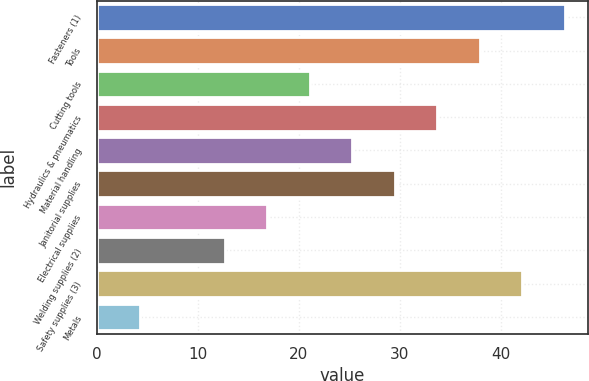<chart> <loc_0><loc_0><loc_500><loc_500><bar_chart><fcel>Fasteners (1)<fcel>Tools<fcel>Cutting tools<fcel>Hydraulics & pneumatics<fcel>Material handling<fcel>Janitorial supplies<fcel>Electrical supplies<fcel>Welding supplies (2)<fcel>Safety supplies (3)<fcel>Metals<nl><fcel>46.3<fcel>37.9<fcel>21.1<fcel>33.7<fcel>25.3<fcel>29.5<fcel>16.9<fcel>12.7<fcel>42.1<fcel>4.3<nl></chart> 